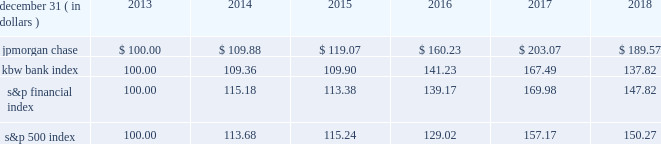Jpmorgan chase & co./2018 form 10-k 41 five-year stock performance the table and graph compare the five-year cumulative total return for jpmorgan chase & co .
( 201cjpmorgan chase 201d or the 201cfirm 201d ) common stock with the cumulative return of the s&p 500 index , the kbw bank index and the s&p financial index .
The s&p 500 index is a commonly referenced equity benchmark in the united states of america ( 201cu.s . 201d ) , consisting of leading companies from different economic sectors .
The kbw bank index seeks to reflect the performance of banks and thrifts that are publicly traded in the u.s .
And is composed of leading national money center and regional banks and thrifts .
The s&p financial index is an index of financial companies , all of which are components of the s&p 500 .
The firm is a component of all three industry indices .
The table and graph assume simultaneous investments of $ 100 on december 31 , 2013 , in jpmorgan chase common stock and in each of the above indices .
The comparison assumes that all dividends are reinvested .
December 31 , ( in dollars ) 2013 2014 2015 2016 2017 2018 .
December 31 , ( in dollars ) .
Did jpmorgan chase outperform the kbw bank index? 
Computations: (189.57 > 137.82)
Answer: yes. 